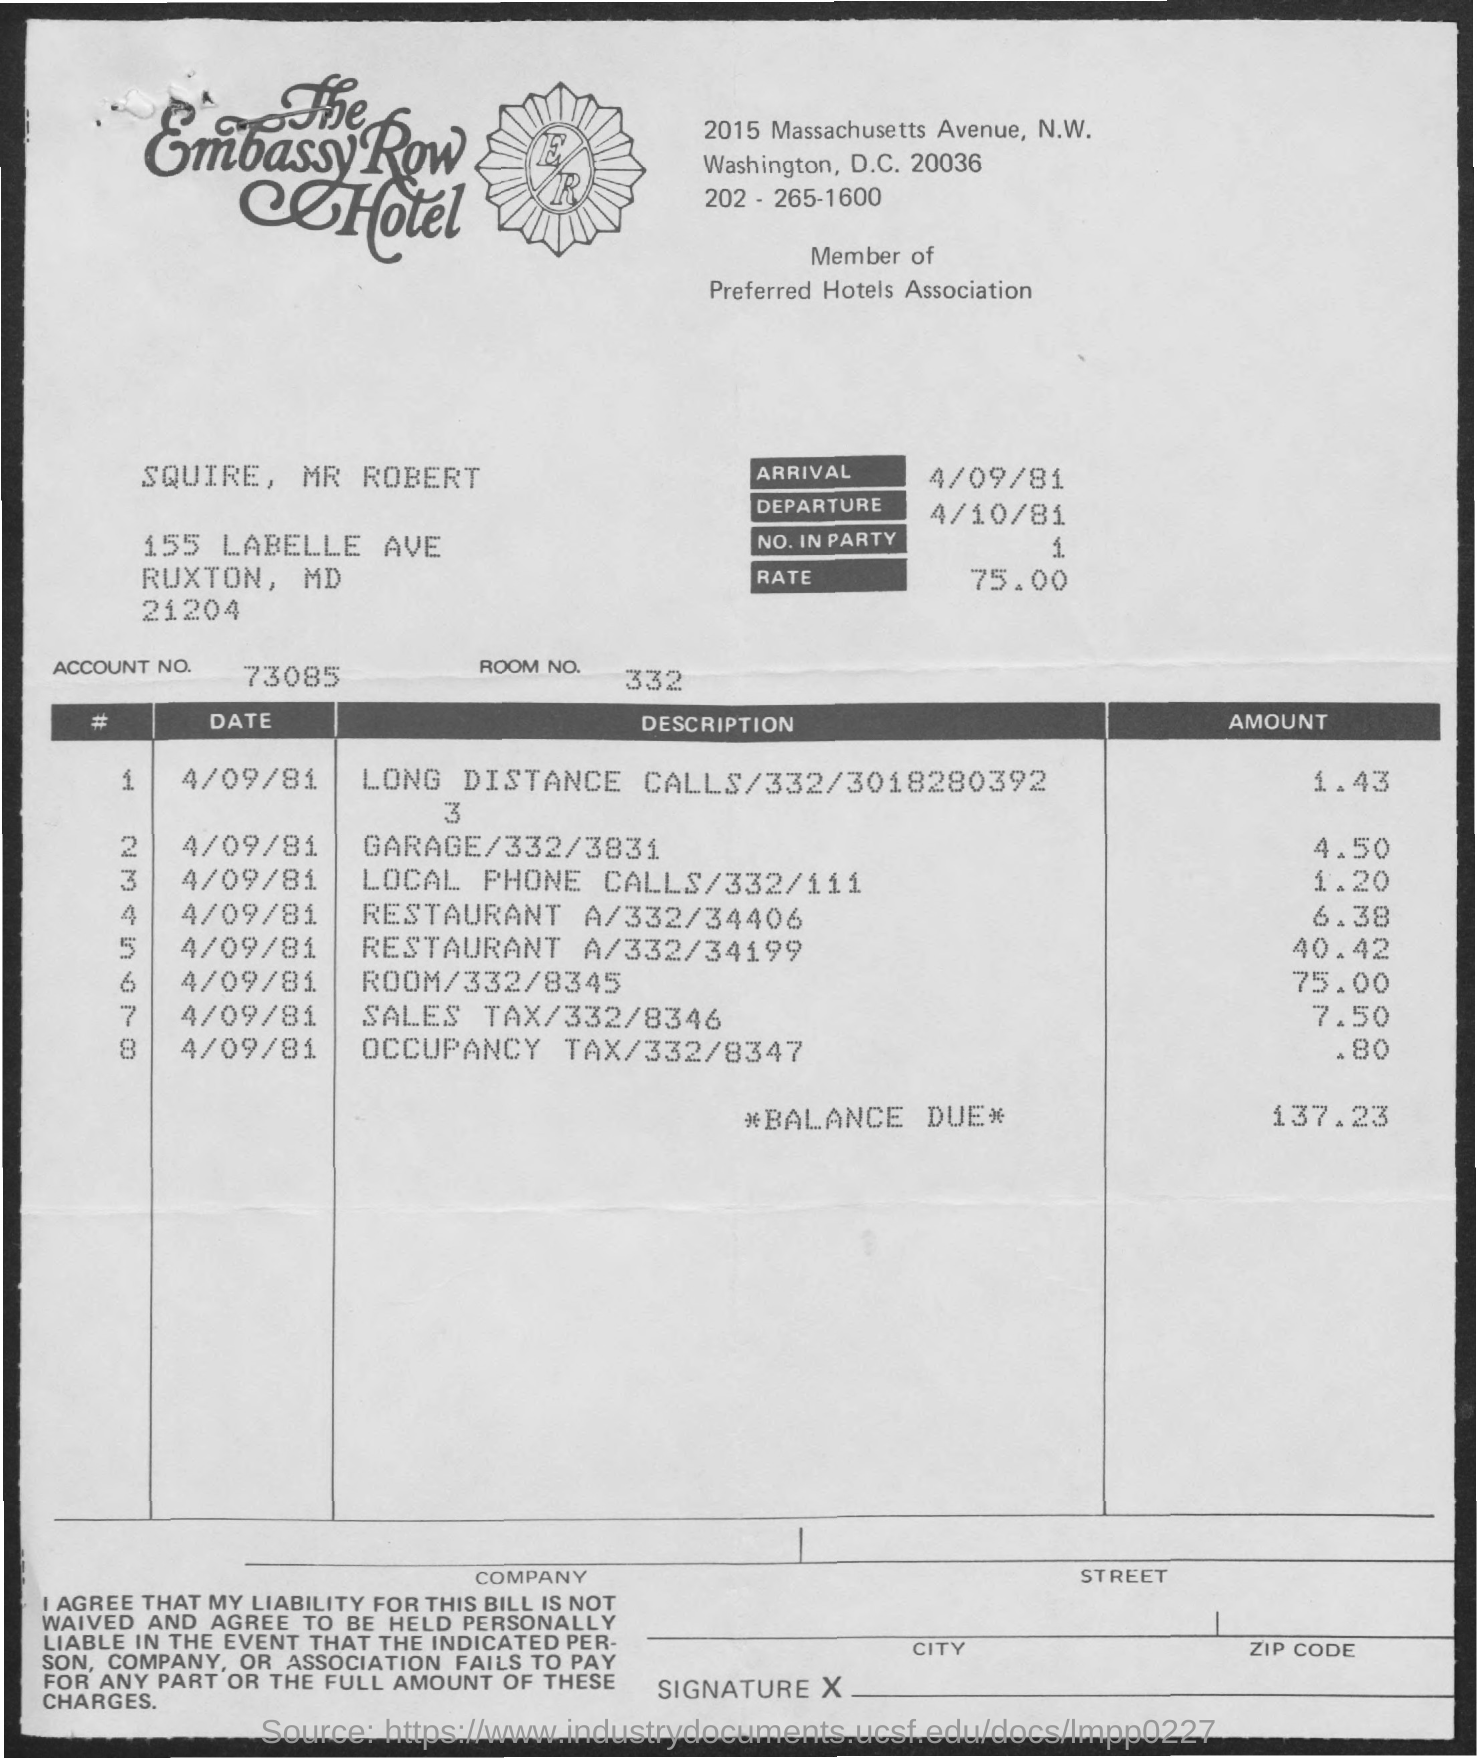Specify some key components in this picture. The balance due mentioned is 137.23 dollars. The occupancy tax mentioned is 0.80. What is the number mentioned in the party?" the man asked, pointing to the one and two on the list. The arrival date mentioned is 4/09/81. The amount for the garage mentioned is 4.50. 